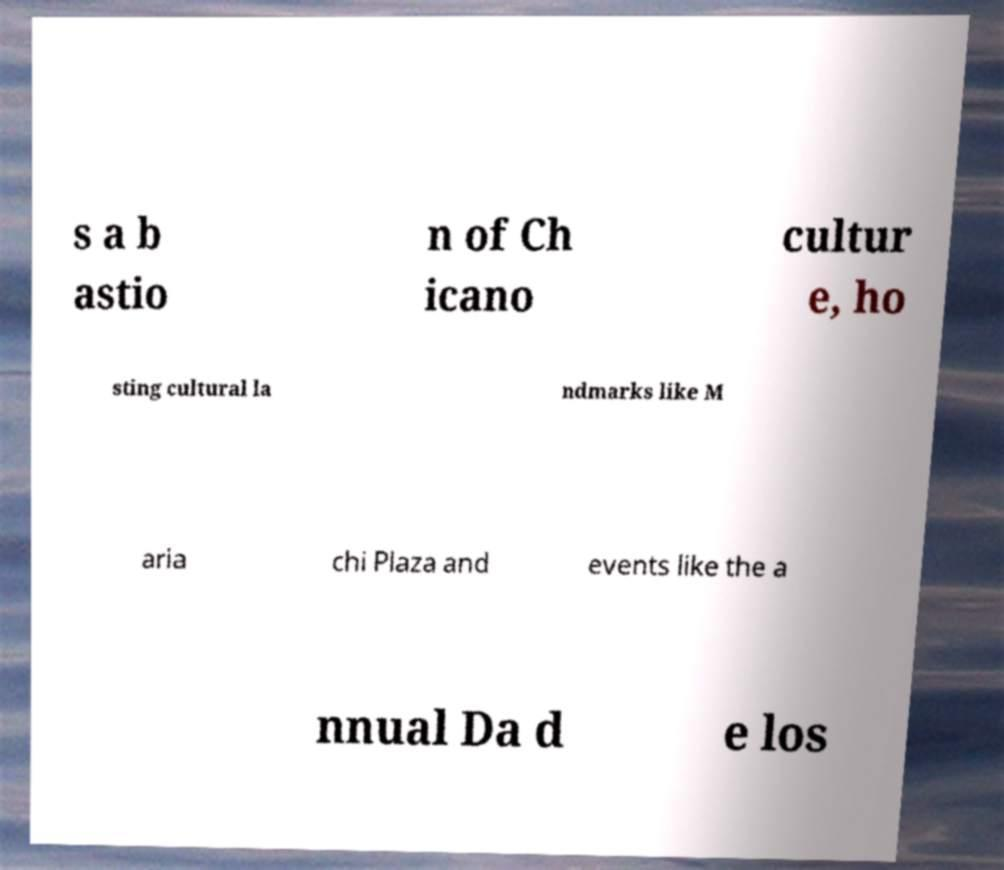There's text embedded in this image that I need extracted. Can you transcribe it verbatim? s a b astio n of Ch icano cultur e, ho sting cultural la ndmarks like M aria chi Plaza and events like the a nnual Da d e los 